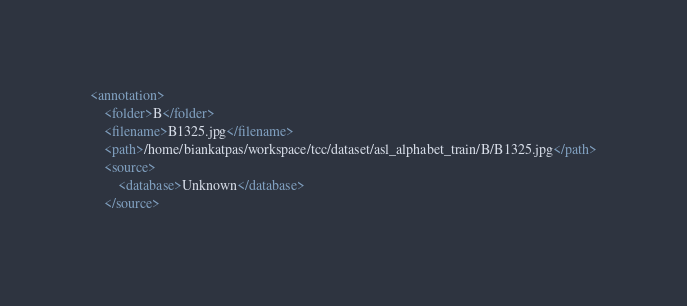<code> <loc_0><loc_0><loc_500><loc_500><_XML_><annotation>
	<folder>B</folder>
	<filename>B1325.jpg</filename>
	<path>/home/biankatpas/workspace/tcc/dataset/asl_alphabet_train/B/B1325.jpg</path>
	<source>
		<database>Unknown</database>
	</source></code> 